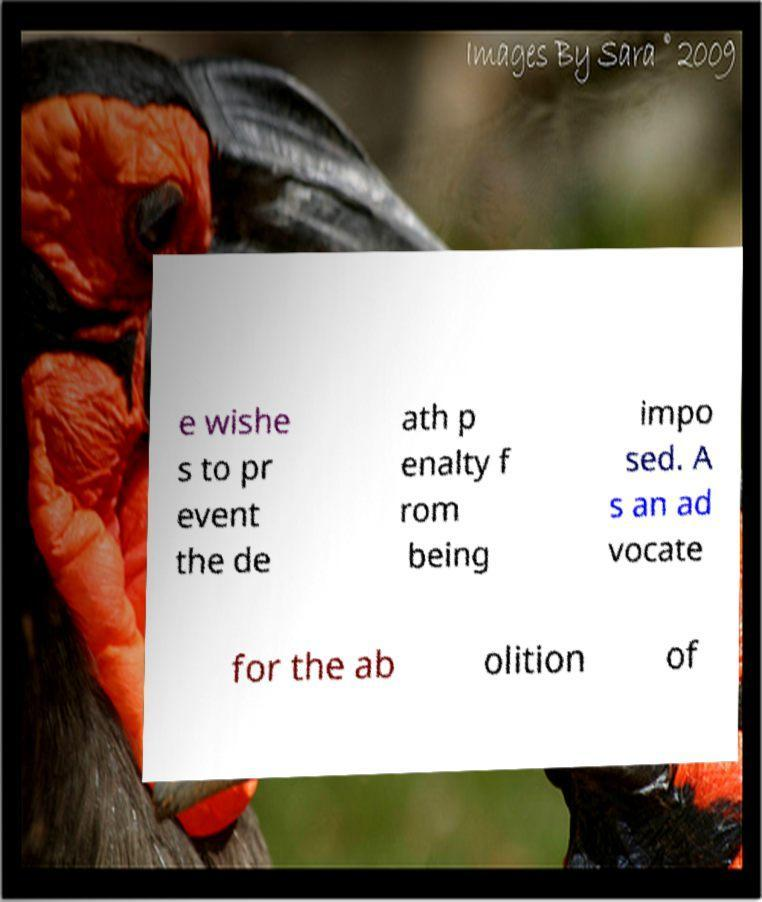For documentation purposes, I need the text within this image transcribed. Could you provide that? e wishe s to pr event the de ath p enalty f rom being impo sed. A s an ad vocate for the ab olition of 